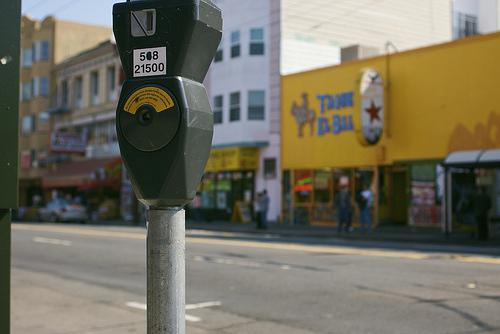Question: what color is the building with the horse sign?
Choices:
A. White.
B. Red.
C. Yellow.
D. Blue.
Answer with the letter. Answer: C Question: where is this picture taken?
Choices:
A. A street.
B. An alley.
C. A beach.
D. A patio.
Answer with the letter. Answer: A Question: how many men are shown?
Choices:
A. Two.
B. Three.
C. Four.
D. Five.
Answer with the letter. Answer: B Question: how is the weather?
Choices:
A. Rainy.
B. Foggy.
C. Sunny.
D. Clear.
Answer with the letter. Answer: D 